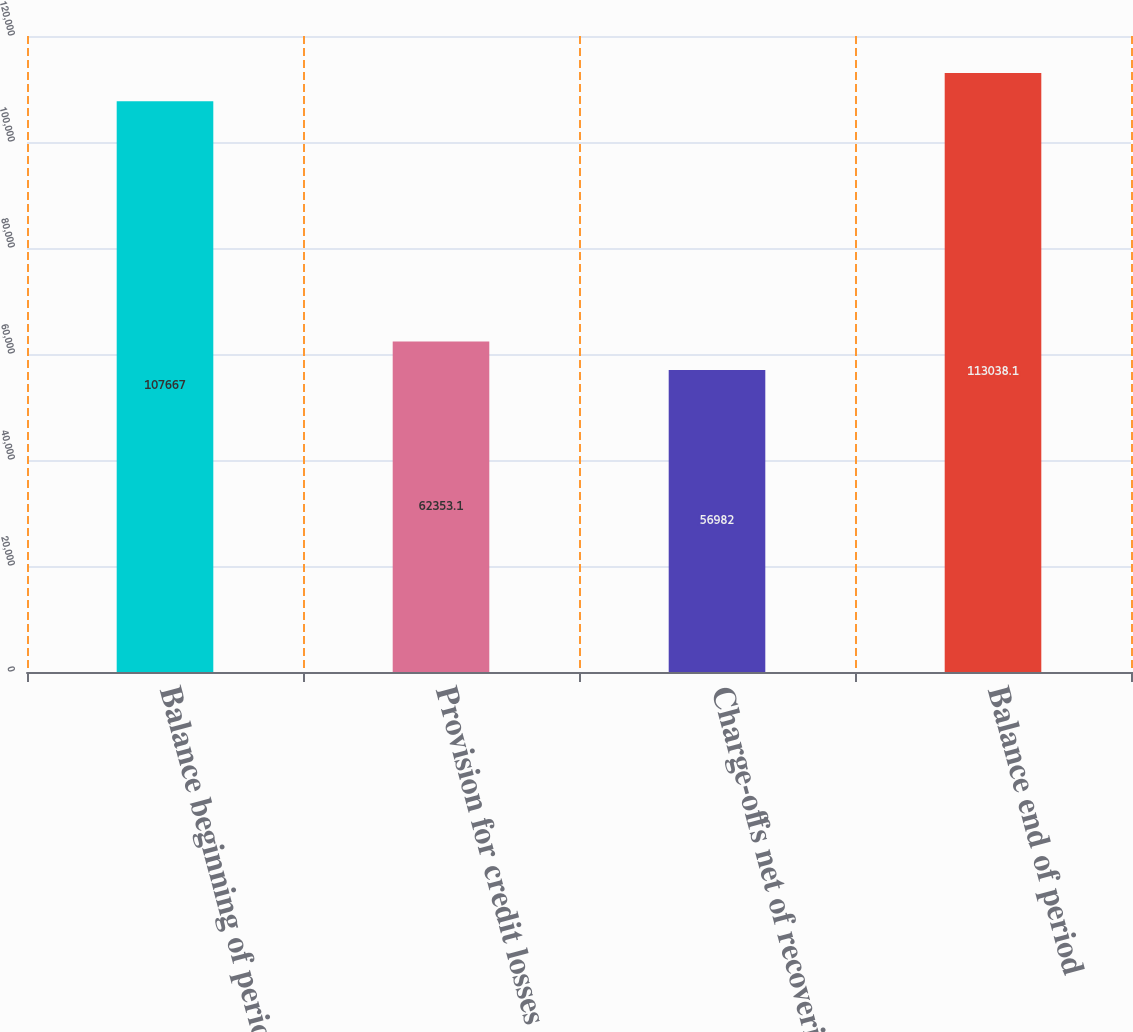<chart> <loc_0><loc_0><loc_500><loc_500><bar_chart><fcel>Balance beginning of period<fcel>Provision for credit losses<fcel>Charge-offs net of recoveries<fcel>Balance end of period<nl><fcel>107667<fcel>62353.1<fcel>56982<fcel>113038<nl></chart> 